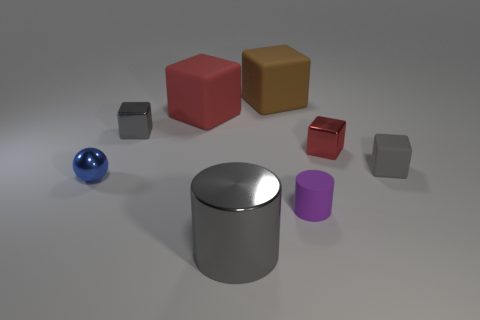Subtract all big rubber cubes. How many cubes are left? 3 Add 2 large rubber blocks. How many objects exist? 10 Subtract all red blocks. How many blocks are left? 3 Subtract all yellow balls. How many gray cubes are left? 2 Subtract all blocks. How many objects are left? 3 Subtract 3 blocks. How many blocks are left? 2 Add 5 large gray cylinders. How many large gray cylinders are left? 6 Add 3 purple objects. How many purple objects exist? 4 Subtract 0 purple spheres. How many objects are left? 8 Subtract all purple spheres. Subtract all red cylinders. How many spheres are left? 1 